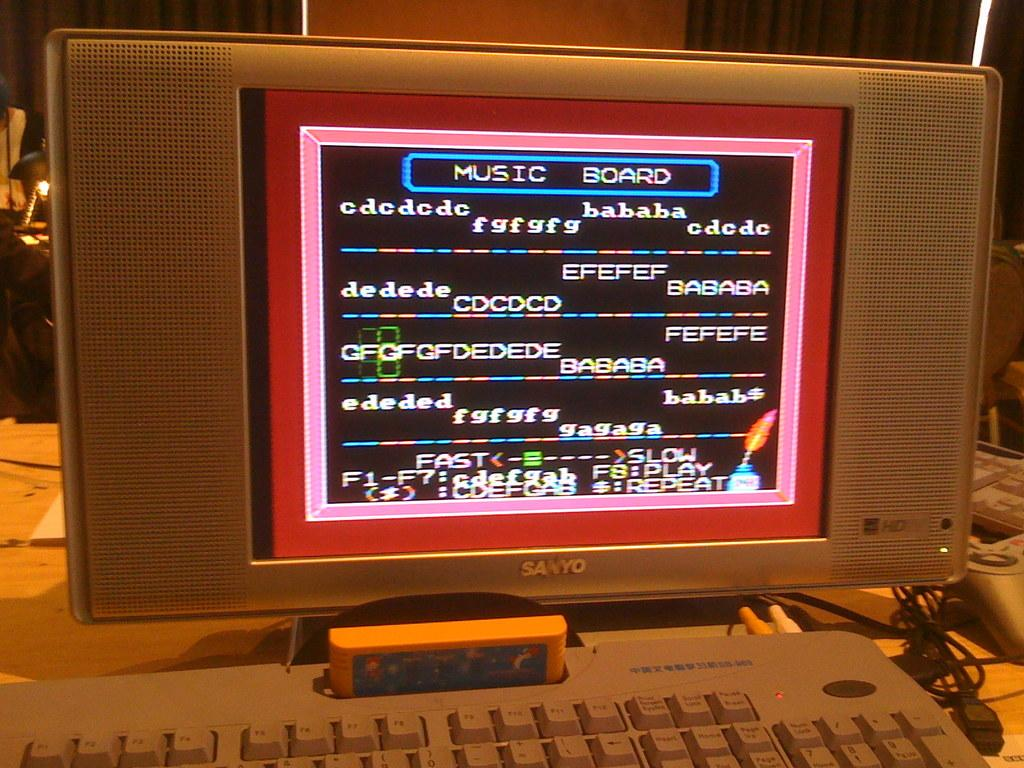Provide a one-sentence caption for the provided image. A music board in which music producers make music. 